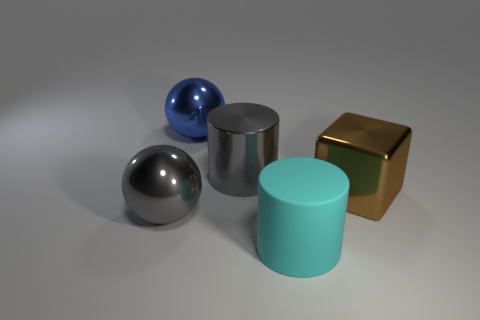What is the size of the metal object that is the same color as the metallic cylinder?
Offer a very short reply. Large. Does the big rubber cylinder have the same color as the cube?
Ensure brevity in your answer.  No. Are there any big matte cylinders that have the same color as the metal cube?
Make the answer very short. No. There is a matte thing that is the same size as the blue shiny ball; what is its color?
Your answer should be compact. Cyan. Are there any other large brown shiny objects of the same shape as the big brown metallic object?
Offer a terse response. No. There is a shiny object that is the same color as the metal cylinder; what shape is it?
Make the answer very short. Sphere. There is a big metallic sphere that is in front of the large ball behind the brown thing; is there a brown shiny object that is right of it?
Make the answer very short. Yes. There is a blue shiny thing that is the same size as the metallic cylinder; what is its shape?
Offer a terse response. Sphere. The other large object that is the same shape as the large rubber object is what color?
Offer a very short reply. Gray. How many objects are large blue metal things or brown blocks?
Ensure brevity in your answer.  2. 